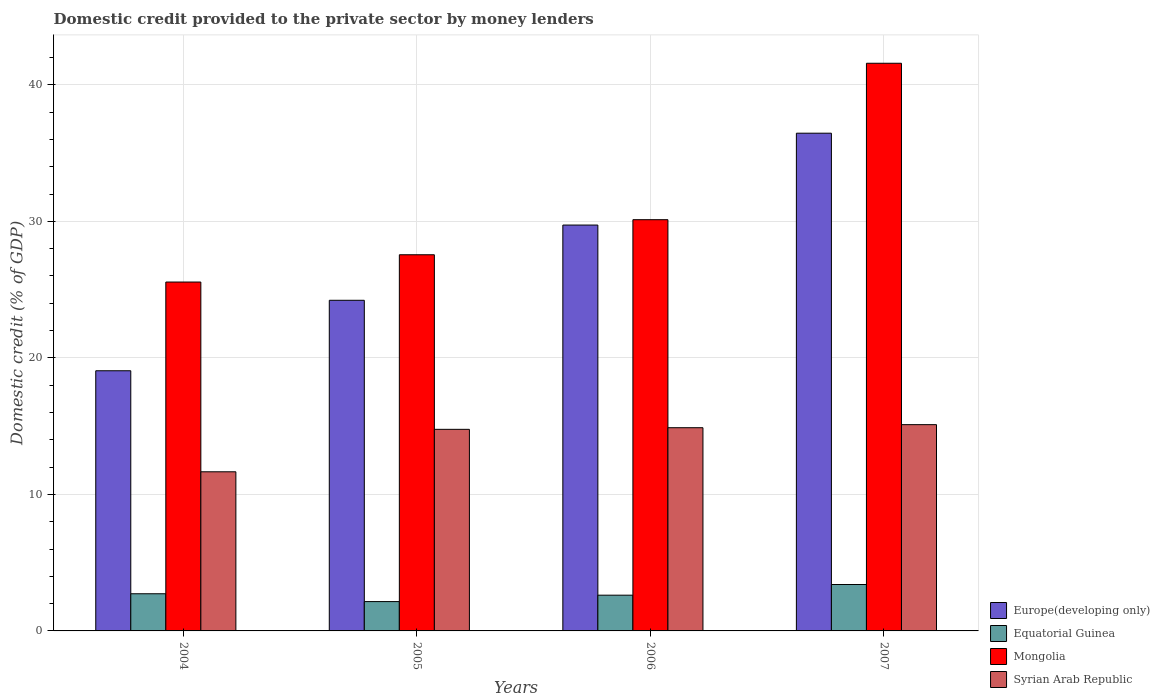How many different coloured bars are there?
Give a very brief answer. 4. How many groups of bars are there?
Your answer should be very brief. 4. Are the number of bars on each tick of the X-axis equal?
Provide a short and direct response. Yes. How many bars are there on the 3rd tick from the left?
Your answer should be very brief. 4. How many bars are there on the 1st tick from the right?
Provide a short and direct response. 4. What is the domestic credit provided to the private sector by money lenders in Europe(developing only) in 2004?
Give a very brief answer. 19.06. Across all years, what is the maximum domestic credit provided to the private sector by money lenders in Mongolia?
Provide a short and direct response. 41.58. Across all years, what is the minimum domestic credit provided to the private sector by money lenders in Europe(developing only)?
Your response must be concise. 19.06. In which year was the domestic credit provided to the private sector by money lenders in Syrian Arab Republic minimum?
Provide a succinct answer. 2004. What is the total domestic credit provided to the private sector by money lenders in Syrian Arab Republic in the graph?
Provide a short and direct response. 56.41. What is the difference between the domestic credit provided to the private sector by money lenders in Europe(developing only) in 2005 and that in 2007?
Ensure brevity in your answer.  -12.24. What is the difference between the domestic credit provided to the private sector by money lenders in Europe(developing only) in 2007 and the domestic credit provided to the private sector by money lenders in Equatorial Guinea in 2005?
Your answer should be very brief. 34.31. What is the average domestic credit provided to the private sector by money lenders in Mongolia per year?
Ensure brevity in your answer.  31.2. In the year 2004, what is the difference between the domestic credit provided to the private sector by money lenders in Mongolia and domestic credit provided to the private sector by money lenders in Syrian Arab Republic?
Your response must be concise. 13.9. What is the ratio of the domestic credit provided to the private sector by money lenders in Mongolia in 2005 to that in 2007?
Keep it short and to the point. 0.66. Is the difference between the domestic credit provided to the private sector by money lenders in Mongolia in 2006 and 2007 greater than the difference between the domestic credit provided to the private sector by money lenders in Syrian Arab Republic in 2006 and 2007?
Your answer should be compact. No. What is the difference between the highest and the second highest domestic credit provided to the private sector by money lenders in Europe(developing only)?
Your response must be concise. 6.73. What is the difference between the highest and the lowest domestic credit provided to the private sector by money lenders in Syrian Arab Republic?
Offer a terse response. 3.45. In how many years, is the domestic credit provided to the private sector by money lenders in Syrian Arab Republic greater than the average domestic credit provided to the private sector by money lenders in Syrian Arab Republic taken over all years?
Give a very brief answer. 3. Is it the case that in every year, the sum of the domestic credit provided to the private sector by money lenders in Mongolia and domestic credit provided to the private sector by money lenders in Europe(developing only) is greater than the sum of domestic credit provided to the private sector by money lenders in Syrian Arab Republic and domestic credit provided to the private sector by money lenders in Equatorial Guinea?
Keep it short and to the point. Yes. What does the 2nd bar from the left in 2004 represents?
Your answer should be very brief. Equatorial Guinea. What does the 1st bar from the right in 2006 represents?
Your response must be concise. Syrian Arab Republic. Is it the case that in every year, the sum of the domestic credit provided to the private sector by money lenders in Equatorial Guinea and domestic credit provided to the private sector by money lenders in Mongolia is greater than the domestic credit provided to the private sector by money lenders in Europe(developing only)?
Your response must be concise. Yes. How many bars are there?
Give a very brief answer. 16. How many years are there in the graph?
Give a very brief answer. 4. Does the graph contain any zero values?
Ensure brevity in your answer.  No. How are the legend labels stacked?
Your answer should be compact. Vertical. What is the title of the graph?
Offer a terse response. Domestic credit provided to the private sector by money lenders. Does "Macao" appear as one of the legend labels in the graph?
Offer a terse response. No. What is the label or title of the X-axis?
Give a very brief answer. Years. What is the label or title of the Y-axis?
Give a very brief answer. Domestic credit (% of GDP). What is the Domestic credit (% of GDP) in Europe(developing only) in 2004?
Provide a succinct answer. 19.06. What is the Domestic credit (% of GDP) in Equatorial Guinea in 2004?
Make the answer very short. 2.72. What is the Domestic credit (% of GDP) in Mongolia in 2004?
Offer a very short reply. 25.55. What is the Domestic credit (% of GDP) in Syrian Arab Republic in 2004?
Offer a terse response. 11.65. What is the Domestic credit (% of GDP) in Europe(developing only) in 2005?
Provide a succinct answer. 24.22. What is the Domestic credit (% of GDP) of Equatorial Guinea in 2005?
Give a very brief answer. 2.15. What is the Domestic credit (% of GDP) of Mongolia in 2005?
Keep it short and to the point. 27.55. What is the Domestic credit (% of GDP) in Syrian Arab Republic in 2005?
Ensure brevity in your answer.  14.76. What is the Domestic credit (% of GDP) in Europe(developing only) in 2006?
Make the answer very short. 29.73. What is the Domestic credit (% of GDP) of Equatorial Guinea in 2006?
Your answer should be compact. 2.62. What is the Domestic credit (% of GDP) in Mongolia in 2006?
Provide a short and direct response. 30.12. What is the Domestic credit (% of GDP) in Syrian Arab Republic in 2006?
Ensure brevity in your answer.  14.88. What is the Domestic credit (% of GDP) of Europe(developing only) in 2007?
Your answer should be very brief. 36.45. What is the Domestic credit (% of GDP) of Equatorial Guinea in 2007?
Provide a succinct answer. 3.4. What is the Domestic credit (% of GDP) of Mongolia in 2007?
Keep it short and to the point. 41.58. What is the Domestic credit (% of GDP) of Syrian Arab Republic in 2007?
Ensure brevity in your answer.  15.11. Across all years, what is the maximum Domestic credit (% of GDP) in Europe(developing only)?
Your response must be concise. 36.45. Across all years, what is the maximum Domestic credit (% of GDP) in Equatorial Guinea?
Your response must be concise. 3.4. Across all years, what is the maximum Domestic credit (% of GDP) of Mongolia?
Your answer should be compact. 41.58. Across all years, what is the maximum Domestic credit (% of GDP) of Syrian Arab Republic?
Your response must be concise. 15.11. Across all years, what is the minimum Domestic credit (% of GDP) of Europe(developing only)?
Your answer should be very brief. 19.06. Across all years, what is the minimum Domestic credit (% of GDP) of Equatorial Guinea?
Offer a terse response. 2.15. Across all years, what is the minimum Domestic credit (% of GDP) of Mongolia?
Ensure brevity in your answer.  25.55. Across all years, what is the minimum Domestic credit (% of GDP) in Syrian Arab Republic?
Your answer should be compact. 11.65. What is the total Domestic credit (% of GDP) of Europe(developing only) in the graph?
Your response must be concise. 109.45. What is the total Domestic credit (% of GDP) of Equatorial Guinea in the graph?
Offer a very short reply. 10.89. What is the total Domestic credit (% of GDP) of Mongolia in the graph?
Provide a succinct answer. 124.8. What is the total Domestic credit (% of GDP) of Syrian Arab Republic in the graph?
Offer a terse response. 56.41. What is the difference between the Domestic credit (% of GDP) in Europe(developing only) in 2004 and that in 2005?
Give a very brief answer. -5.16. What is the difference between the Domestic credit (% of GDP) in Equatorial Guinea in 2004 and that in 2005?
Ensure brevity in your answer.  0.57. What is the difference between the Domestic credit (% of GDP) of Mongolia in 2004 and that in 2005?
Provide a succinct answer. -2. What is the difference between the Domestic credit (% of GDP) of Syrian Arab Republic in 2004 and that in 2005?
Your answer should be compact. -3.11. What is the difference between the Domestic credit (% of GDP) of Europe(developing only) in 2004 and that in 2006?
Give a very brief answer. -10.67. What is the difference between the Domestic credit (% of GDP) of Equatorial Guinea in 2004 and that in 2006?
Offer a terse response. 0.1. What is the difference between the Domestic credit (% of GDP) of Mongolia in 2004 and that in 2006?
Your response must be concise. -4.57. What is the difference between the Domestic credit (% of GDP) of Syrian Arab Republic in 2004 and that in 2006?
Your answer should be compact. -3.23. What is the difference between the Domestic credit (% of GDP) of Europe(developing only) in 2004 and that in 2007?
Give a very brief answer. -17.4. What is the difference between the Domestic credit (% of GDP) in Equatorial Guinea in 2004 and that in 2007?
Give a very brief answer. -0.68. What is the difference between the Domestic credit (% of GDP) of Mongolia in 2004 and that in 2007?
Give a very brief answer. -16.02. What is the difference between the Domestic credit (% of GDP) in Syrian Arab Republic in 2004 and that in 2007?
Your response must be concise. -3.45. What is the difference between the Domestic credit (% of GDP) of Europe(developing only) in 2005 and that in 2006?
Ensure brevity in your answer.  -5.51. What is the difference between the Domestic credit (% of GDP) in Equatorial Guinea in 2005 and that in 2006?
Ensure brevity in your answer.  -0.47. What is the difference between the Domestic credit (% of GDP) of Mongolia in 2005 and that in 2006?
Your answer should be very brief. -2.57. What is the difference between the Domestic credit (% of GDP) of Syrian Arab Republic in 2005 and that in 2006?
Make the answer very short. -0.12. What is the difference between the Domestic credit (% of GDP) in Europe(developing only) in 2005 and that in 2007?
Provide a succinct answer. -12.24. What is the difference between the Domestic credit (% of GDP) of Equatorial Guinea in 2005 and that in 2007?
Your response must be concise. -1.25. What is the difference between the Domestic credit (% of GDP) of Mongolia in 2005 and that in 2007?
Give a very brief answer. -14.03. What is the difference between the Domestic credit (% of GDP) in Syrian Arab Republic in 2005 and that in 2007?
Your response must be concise. -0.34. What is the difference between the Domestic credit (% of GDP) in Europe(developing only) in 2006 and that in 2007?
Your answer should be compact. -6.73. What is the difference between the Domestic credit (% of GDP) in Equatorial Guinea in 2006 and that in 2007?
Provide a succinct answer. -0.78. What is the difference between the Domestic credit (% of GDP) in Mongolia in 2006 and that in 2007?
Your response must be concise. -11.46. What is the difference between the Domestic credit (% of GDP) of Syrian Arab Republic in 2006 and that in 2007?
Give a very brief answer. -0.22. What is the difference between the Domestic credit (% of GDP) in Europe(developing only) in 2004 and the Domestic credit (% of GDP) in Equatorial Guinea in 2005?
Keep it short and to the point. 16.91. What is the difference between the Domestic credit (% of GDP) of Europe(developing only) in 2004 and the Domestic credit (% of GDP) of Mongolia in 2005?
Your answer should be compact. -8.5. What is the difference between the Domestic credit (% of GDP) in Europe(developing only) in 2004 and the Domestic credit (% of GDP) in Syrian Arab Republic in 2005?
Make the answer very short. 4.29. What is the difference between the Domestic credit (% of GDP) in Equatorial Guinea in 2004 and the Domestic credit (% of GDP) in Mongolia in 2005?
Your response must be concise. -24.83. What is the difference between the Domestic credit (% of GDP) in Equatorial Guinea in 2004 and the Domestic credit (% of GDP) in Syrian Arab Republic in 2005?
Give a very brief answer. -12.04. What is the difference between the Domestic credit (% of GDP) in Mongolia in 2004 and the Domestic credit (% of GDP) in Syrian Arab Republic in 2005?
Make the answer very short. 10.79. What is the difference between the Domestic credit (% of GDP) in Europe(developing only) in 2004 and the Domestic credit (% of GDP) in Equatorial Guinea in 2006?
Ensure brevity in your answer.  16.44. What is the difference between the Domestic credit (% of GDP) of Europe(developing only) in 2004 and the Domestic credit (% of GDP) of Mongolia in 2006?
Provide a succinct answer. -11.06. What is the difference between the Domestic credit (% of GDP) of Europe(developing only) in 2004 and the Domestic credit (% of GDP) of Syrian Arab Republic in 2006?
Make the answer very short. 4.17. What is the difference between the Domestic credit (% of GDP) of Equatorial Guinea in 2004 and the Domestic credit (% of GDP) of Mongolia in 2006?
Offer a terse response. -27.4. What is the difference between the Domestic credit (% of GDP) of Equatorial Guinea in 2004 and the Domestic credit (% of GDP) of Syrian Arab Republic in 2006?
Provide a succinct answer. -12.16. What is the difference between the Domestic credit (% of GDP) of Mongolia in 2004 and the Domestic credit (% of GDP) of Syrian Arab Republic in 2006?
Provide a short and direct response. 10.67. What is the difference between the Domestic credit (% of GDP) of Europe(developing only) in 2004 and the Domestic credit (% of GDP) of Equatorial Guinea in 2007?
Your answer should be very brief. 15.66. What is the difference between the Domestic credit (% of GDP) of Europe(developing only) in 2004 and the Domestic credit (% of GDP) of Mongolia in 2007?
Offer a terse response. -22.52. What is the difference between the Domestic credit (% of GDP) in Europe(developing only) in 2004 and the Domestic credit (% of GDP) in Syrian Arab Republic in 2007?
Your answer should be compact. 3.95. What is the difference between the Domestic credit (% of GDP) in Equatorial Guinea in 2004 and the Domestic credit (% of GDP) in Mongolia in 2007?
Offer a terse response. -38.85. What is the difference between the Domestic credit (% of GDP) in Equatorial Guinea in 2004 and the Domestic credit (% of GDP) in Syrian Arab Republic in 2007?
Your response must be concise. -12.39. What is the difference between the Domestic credit (% of GDP) of Mongolia in 2004 and the Domestic credit (% of GDP) of Syrian Arab Republic in 2007?
Your response must be concise. 10.45. What is the difference between the Domestic credit (% of GDP) in Europe(developing only) in 2005 and the Domestic credit (% of GDP) in Equatorial Guinea in 2006?
Make the answer very short. 21.6. What is the difference between the Domestic credit (% of GDP) in Europe(developing only) in 2005 and the Domestic credit (% of GDP) in Mongolia in 2006?
Provide a short and direct response. -5.9. What is the difference between the Domestic credit (% of GDP) of Europe(developing only) in 2005 and the Domestic credit (% of GDP) of Syrian Arab Republic in 2006?
Offer a very short reply. 9.33. What is the difference between the Domestic credit (% of GDP) of Equatorial Guinea in 2005 and the Domestic credit (% of GDP) of Mongolia in 2006?
Your answer should be compact. -27.97. What is the difference between the Domestic credit (% of GDP) in Equatorial Guinea in 2005 and the Domestic credit (% of GDP) in Syrian Arab Republic in 2006?
Provide a succinct answer. -12.73. What is the difference between the Domestic credit (% of GDP) of Mongolia in 2005 and the Domestic credit (% of GDP) of Syrian Arab Republic in 2006?
Offer a terse response. 12.67. What is the difference between the Domestic credit (% of GDP) of Europe(developing only) in 2005 and the Domestic credit (% of GDP) of Equatorial Guinea in 2007?
Offer a very short reply. 20.82. What is the difference between the Domestic credit (% of GDP) in Europe(developing only) in 2005 and the Domestic credit (% of GDP) in Mongolia in 2007?
Keep it short and to the point. -17.36. What is the difference between the Domestic credit (% of GDP) in Europe(developing only) in 2005 and the Domestic credit (% of GDP) in Syrian Arab Republic in 2007?
Provide a short and direct response. 9.11. What is the difference between the Domestic credit (% of GDP) of Equatorial Guinea in 2005 and the Domestic credit (% of GDP) of Mongolia in 2007?
Offer a very short reply. -39.43. What is the difference between the Domestic credit (% of GDP) of Equatorial Guinea in 2005 and the Domestic credit (% of GDP) of Syrian Arab Republic in 2007?
Offer a terse response. -12.96. What is the difference between the Domestic credit (% of GDP) of Mongolia in 2005 and the Domestic credit (% of GDP) of Syrian Arab Republic in 2007?
Your response must be concise. 12.44. What is the difference between the Domestic credit (% of GDP) in Europe(developing only) in 2006 and the Domestic credit (% of GDP) in Equatorial Guinea in 2007?
Keep it short and to the point. 26.33. What is the difference between the Domestic credit (% of GDP) of Europe(developing only) in 2006 and the Domestic credit (% of GDP) of Mongolia in 2007?
Ensure brevity in your answer.  -11.85. What is the difference between the Domestic credit (% of GDP) in Europe(developing only) in 2006 and the Domestic credit (% of GDP) in Syrian Arab Republic in 2007?
Your answer should be compact. 14.62. What is the difference between the Domestic credit (% of GDP) of Equatorial Guinea in 2006 and the Domestic credit (% of GDP) of Mongolia in 2007?
Keep it short and to the point. -38.96. What is the difference between the Domestic credit (% of GDP) in Equatorial Guinea in 2006 and the Domestic credit (% of GDP) in Syrian Arab Republic in 2007?
Provide a short and direct response. -12.49. What is the difference between the Domestic credit (% of GDP) in Mongolia in 2006 and the Domestic credit (% of GDP) in Syrian Arab Republic in 2007?
Keep it short and to the point. 15.01. What is the average Domestic credit (% of GDP) of Europe(developing only) per year?
Your response must be concise. 27.36. What is the average Domestic credit (% of GDP) in Equatorial Guinea per year?
Make the answer very short. 2.72. What is the average Domestic credit (% of GDP) of Mongolia per year?
Give a very brief answer. 31.2. What is the average Domestic credit (% of GDP) in Syrian Arab Republic per year?
Provide a succinct answer. 14.1. In the year 2004, what is the difference between the Domestic credit (% of GDP) of Europe(developing only) and Domestic credit (% of GDP) of Equatorial Guinea?
Your response must be concise. 16.33. In the year 2004, what is the difference between the Domestic credit (% of GDP) in Europe(developing only) and Domestic credit (% of GDP) in Mongolia?
Your response must be concise. -6.5. In the year 2004, what is the difference between the Domestic credit (% of GDP) of Europe(developing only) and Domestic credit (% of GDP) of Syrian Arab Republic?
Your answer should be very brief. 7.4. In the year 2004, what is the difference between the Domestic credit (% of GDP) in Equatorial Guinea and Domestic credit (% of GDP) in Mongolia?
Keep it short and to the point. -22.83. In the year 2004, what is the difference between the Domestic credit (% of GDP) of Equatorial Guinea and Domestic credit (% of GDP) of Syrian Arab Republic?
Make the answer very short. -8.93. In the year 2004, what is the difference between the Domestic credit (% of GDP) of Mongolia and Domestic credit (% of GDP) of Syrian Arab Republic?
Provide a succinct answer. 13.9. In the year 2005, what is the difference between the Domestic credit (% of GDP) of Europe(developing only) and Domestic credit (% of GDP) of Equatorial Guinea?
Provide a short and direct response. 22.07. In the year 2005, what is the difference between the Domestic credit (% of GDP) of Europe(developing only) and Domestic credit (% of GDP) of Mongolia?
Your response must be concise. -3.33. In the year 2005, what is the difference between the Domestic credit (% of GDP) of Europe(developing only) and Domestic credit (% of GDP) of Syrian Arab Republic?
Give a very brief answer. 9.45. In the year 2005, what is the difference between the Domestic credit (% of GDP) in Equatorial Guinea and Domestic credit (% of GDP) in Mongolia?
Keep it short and to the point. -25.4. In the year 2005, what is the difference between the Domestic credit (% of GDP) in Equatorial Guinea and Domestic credit (% of GDP) in Syrian Arab Republic?
Ensure brevity in your answer.  -12.62. In the year 2005, what is the difference between the Domestic credit (% of GDP) of Mongolia and Domestic credit (% of GDP) of Syrian Arab Republic?
Offer a terse response. 12.79. In the year 2006, what is the difference between the Domestic credit (% of GDP) in Europe(developing only) and Domestic credit (% of GDP) in Equatorial Guinea?
Offer a very short reply. 27.11. In the year 2006, what is the difference between the Domestic credit (% of GDP) in Europe(developing only) and Domestic credit (% of GDP) in Mongolia?
Provide a short and direct response. -0.39. In the year 2006, what is the difference between the Domestic credit (% of GDP) in Europe(developing only) and Domestic credit (% of GDP) in Syrian Arab Republic?
Provide a succinct answer. 14.84. In the year 2006, what is the difference between the Domestic credit (% of GDP) in Equatorial Guinea and Domestic credit (% of GDP) in Mongolia?
Your response must be concise. -27.5. In the year 2006, what is the difference between the Domestic credit (% of GDP) in Equatorial Guinea and Domestic credit (% of GDP) in Syrian Arab Republic?
Your answer should be compact. -12.27. In the year 2006, what is the difference between the Domestic credit (% of GDP) of Mongolia and Domestic credit (% of GDP) of Syrian Arab Republic?
Give a very brief answer. 15.24. In the year 2007, what is the difference between the Domestic credit (% of GDP) in Europe(developing only) and Domestic credit (% of GDP) in Equatorial Guinea?
Your response must be concise. 33.06. In the year 2007, what is the difference between the Domestic credit (% of GDP) of Europe(developing only) and Domestic credit (% of GDP) of Mongolia?
Offer a terse response. -5.12. In the year 2007, what is the difference between the Domestic credit (% of GDP) in Europe(developing only) and Domestic credit (% of GDP) in Syrian Arab Republic?
Offer a very short reply. 21.35. In the year 2007, what is the difference between the Domestic credit (% of GDP) of Equatorial Guinea and Domestic credit (% of GDP) of Mongolia?
Your answer should be compact. -38.18. In the year 2007, what is the difference between the Domestic credit (% of GDP) of Equatorial Guinea and Domestic credit (% of GDP) of Syrian Arab Republic?
Your response must be concise. -11.71. In the year 2007, what is the difference between the Domestic credit (% of GDP) in Mongolia and Domestic credit (% of GDP) in Syrian Arab Republic?
Your answer should be very brief. 26.47. What is the ratio of the Domestic credit (% of GDP) of Europe(developing only) in 2004 to that in 2005?
Offer a very short reply. 0.79. What is the ratio of the Domestic credit (% of GDP) in Equatorial Guinea in 2004 to that in 2005?
Provide a succinct answer. 1.27. What is the ratio of the Domestic credit (% of GDP) in Mongolia in 2004 to that in 2005?
Provide a succinct answer. 0.93. What is the ratio of the Domestic credit (% of GDP) in Syrian Arab Republic in 2004 to that in 2005?
Provide a short and direct response. 0.79. What is the ratio of the Domestic credit (% of GDP) of Europe(developing only) in 2004 to that in 2006?
Give a very brief answer. 0.64. What is the ratio of the Domestic credit (% of GDP) of Equatorial Guinea in 2004 to that in 2006?
Provide a short and direct response. 1.04. What is the ratio of the Domestic credit (% of GDP) of Mongolia in 2004 to that in 2006?
Provide a short and direct response. 0.85. What is the ratio of the Domestic credit (% of GDP) in Syrian Arab Republic in 2004 to that in 2006?
Your response must be concise. 0.78. What is the ratio of the Domestic credit (% of GDP) of Europe(developing only) in 2004 to that in 2007?
Your response must be concise. 0.52. What is the ratio of the Domestic credit (% of GDP) of Equatorial Guinea in 2004 to that in 2007?
Ensure brevity in your answer.  0.8. What is the ratio of the Domestic credit (% of GDP) of Mongolia in 2004 to that in 2007?
Your response must be concise. 0.61. What is the ratio of the Domestic credit (% of GDP) in Syrian Arab Republic in 2004 to that in 2007?
Your answer should be very brief. 0.77. What is the ratio of the Domestic credit (% of GDP) of Europe(developing only) in 2005 to that in 2006?
Offer a terse response. 0.81. What is the ratio of the Domestic credit (% of GDP) of Equatorial Guinea in 2005 to that in 2006?
Make the answer very short. 0.82. What is the ratio of the Domestic credit (% of GDP) in Mongolia in 2005 to that in 2006?
Keep it short and to the point. 0.91. What is the ratio of the Domestic credit (% of GDP) of Europe(developing only) in 2005 to that in 2007?
Your answer should be compact. 0.66. What is the ratio of the Domestic credit (% of GDP) of Equatorial Guinea in 2005 to that in 2007?
Provide a short and direct response. 0.63. What is the ratio of the Domestic credit (% of GDP) in Mongolia in 2005 to that in 2007?
Offer a terse response. 0.66. What is the ratio of the Domestic credit (% of GDP) in Syrian Arab Republic in 2005 to that in 2007?
Make the answer very short. 0.98. What is the ratio of the Domestic credit (% of GDP) of Europe(developing only) in 2006 to that in 2007?
Your answer should be very brief. 0.82. What is the ratio of the Domestic credit (% of GDP) of Equatorial Guinea in 2006 to that in 2007?
Make the answer very short. 0.77. What is the ratio of the Domestic credit (% of GDP) in Mongolia in 2006 to that in 2007?
Provide a short and direct response. 0.72. What is the ratio of the Domestic credit (% of GDP) in Syrian Arab Republic in 2006 to that in 2007?
Offer a terse response. 0.99. What is the difference between the highest and the second highest Domestic credit (% of GDP) of Europe(developing only)?
Your answer should be compact. 6.73. What is the difference between the highest and the second highest Domestic credit (% of GDP) of Equatorial Guinea?
Ensure brevity in your answer.  0.68. What is the difference between the highest and the second highest Domestic credit (% of GDP) in Mongolia?
Your answer should be very brief. 11.46. What is the difference between the highest and the second highest Domestic credit (% of GDP) of Syrian Arab Republic?
Make the answer very short. 0.22. What is the difference between the highest and the lowest Domestic credit (% of GDP) in Europe(developing only)?
Offer a terse response. 17.4. What is the difference between the highest and the lowest Domestic credit (% of GDP) in Equatorial Guinea?
Offer a terse response. 1.25. What is the difference between the highest and the lowest Domestic credit (% of GDP) in Mongolia?
Provide a short and direct response. 16.02. What is the difference between the highest and the lowest Domestic credit (% of GDP) in Syrian Arab Republic?
Your answer should be very brief. 3.45. 